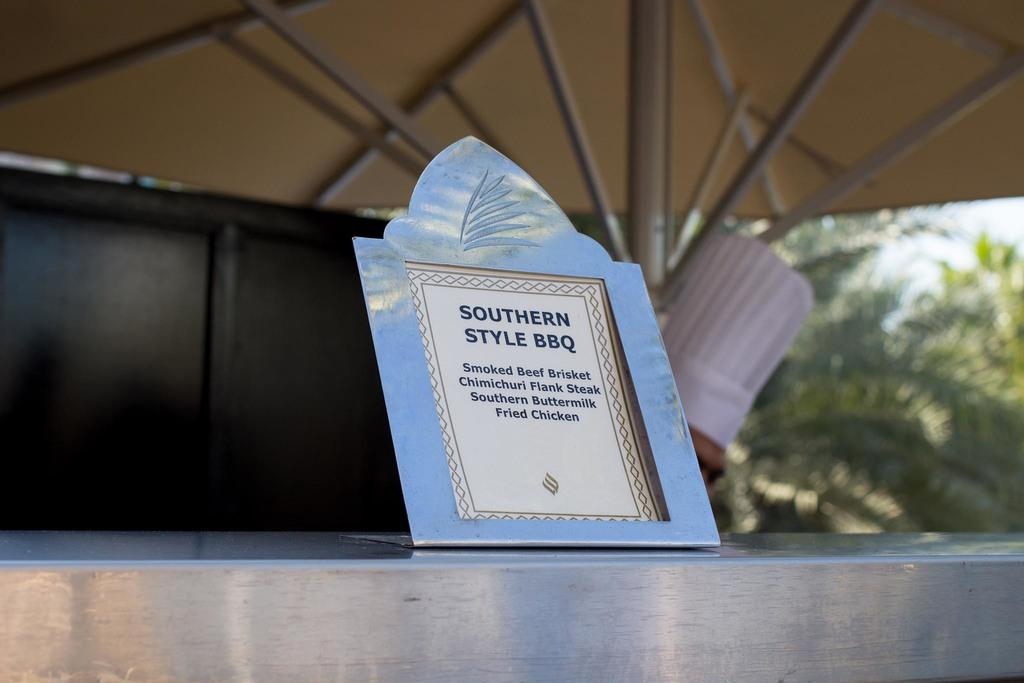What is the main object in the image? There is a board in the image. What is the board placed on? The board is on a steel surface. What can be seen in the background of the image? There is a tree in the background of the image. Can you see any airplanes taking off or landing at the airport in the image? There is no airport or airplanes present in the image. What type of bread is visible on the board in the image? There is no bread present in the image; it only features a board on a steel surface and a tree in the background. 